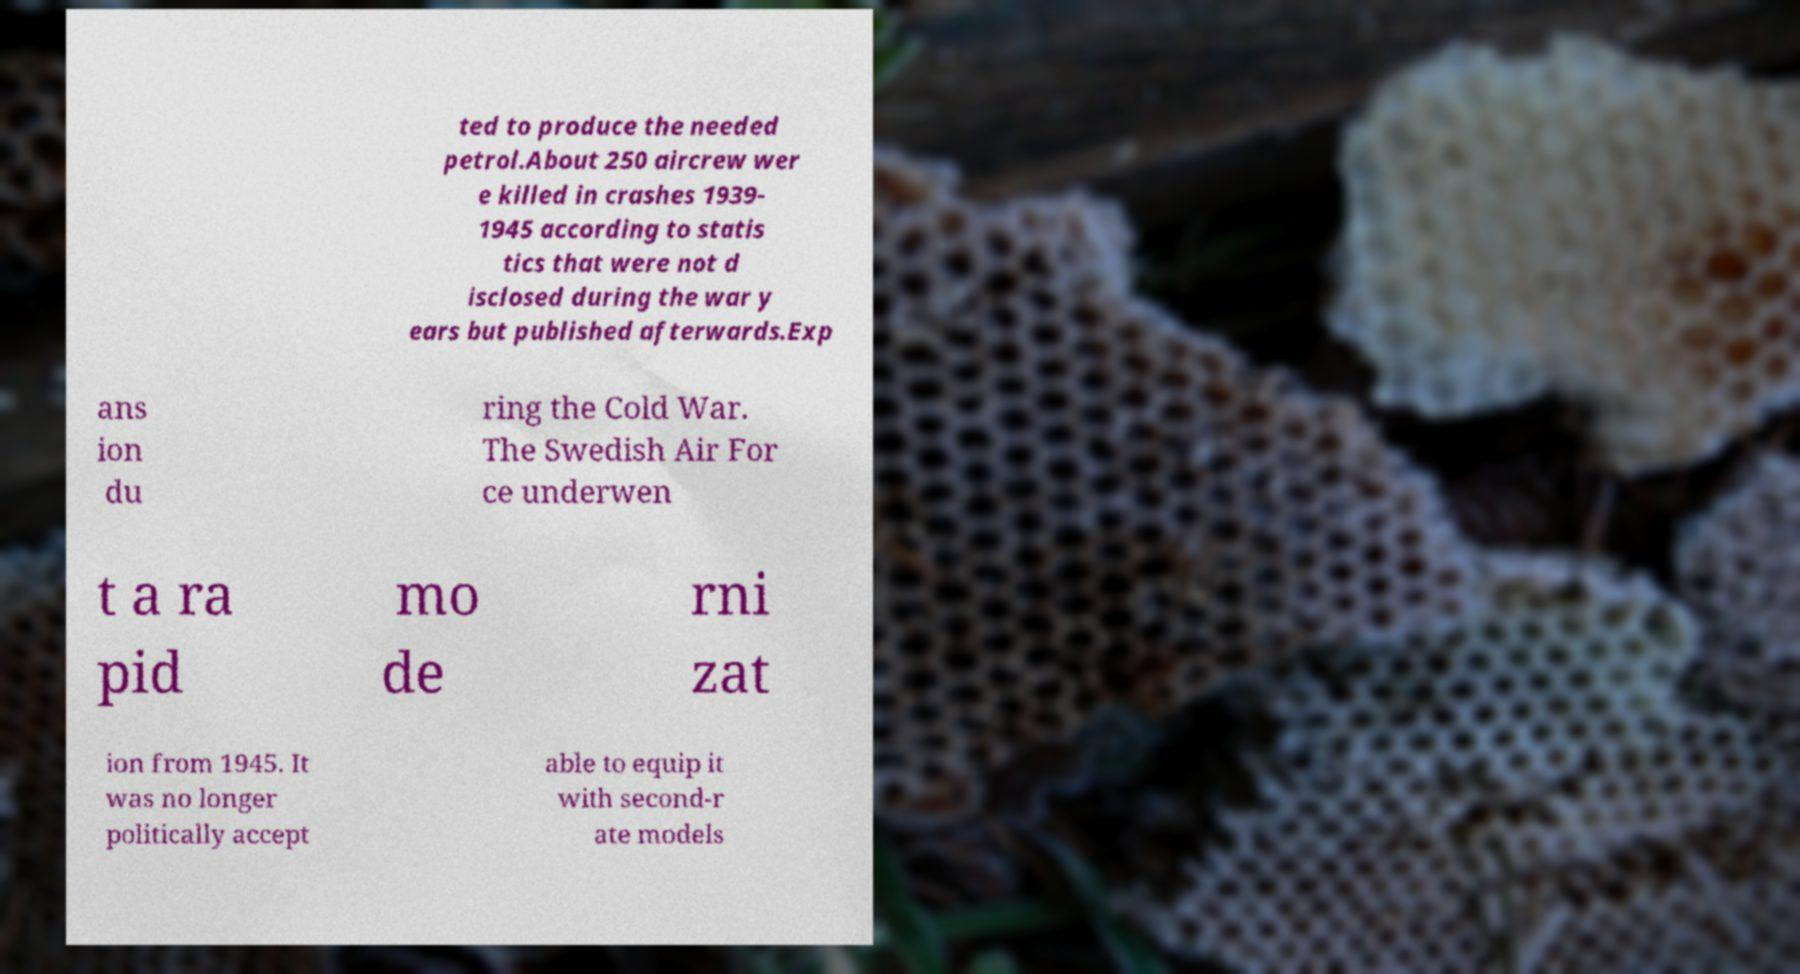For documentation purposes, I need the text within this image transcribed. Could you provide that? ted to produce the needed petrol.About 250 aircrew wer e killed in crashes 1939- 1945 according to statis tics that were not d isclosed during the war y ears but published afterwards.Exp ans ion du ring the Cold War. The Swedish Air For ce underwen t a ra pid mo de rni zat ion from 1945. It was no longer politically accept able to equip it with second-r ate models 